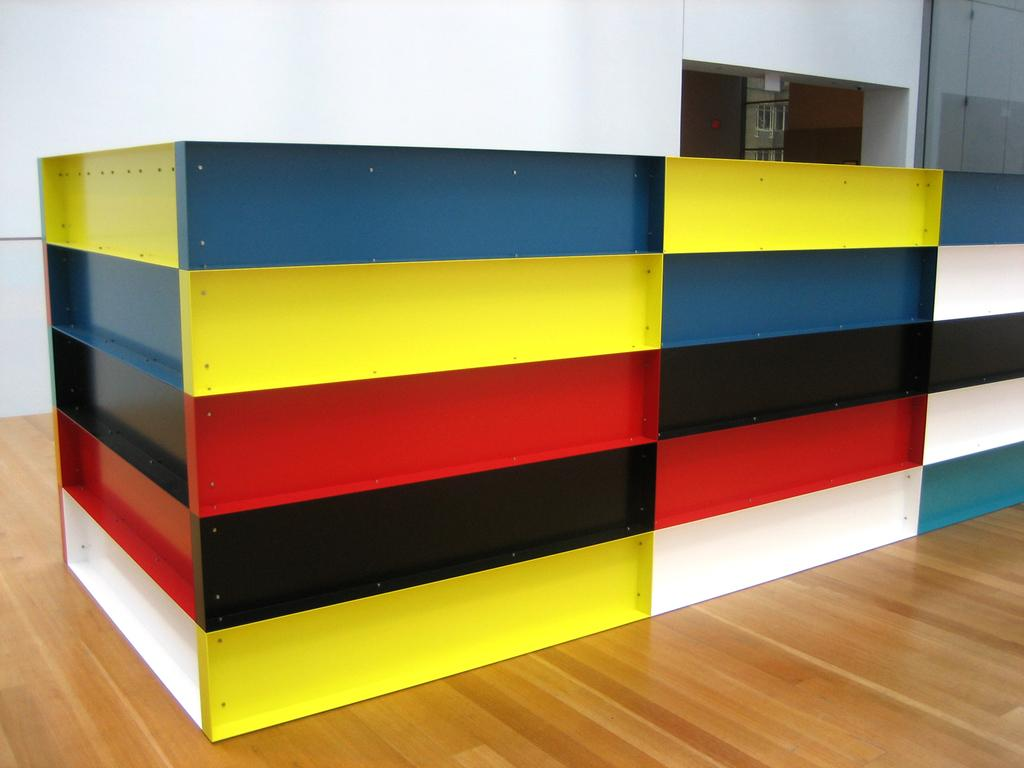What is the main object on the wooden platform in the image? The facts provided do not specify the type of object on the wooden platform. What can be seen behind the wooden platform in the image? There is a wall visible in the background of the image. Are there any other objects or features in the background of the image? Yes, there are objects present in the background of the image. How does the iron help with digestion in the image? There is no iron or reference to digestion present in the image. 